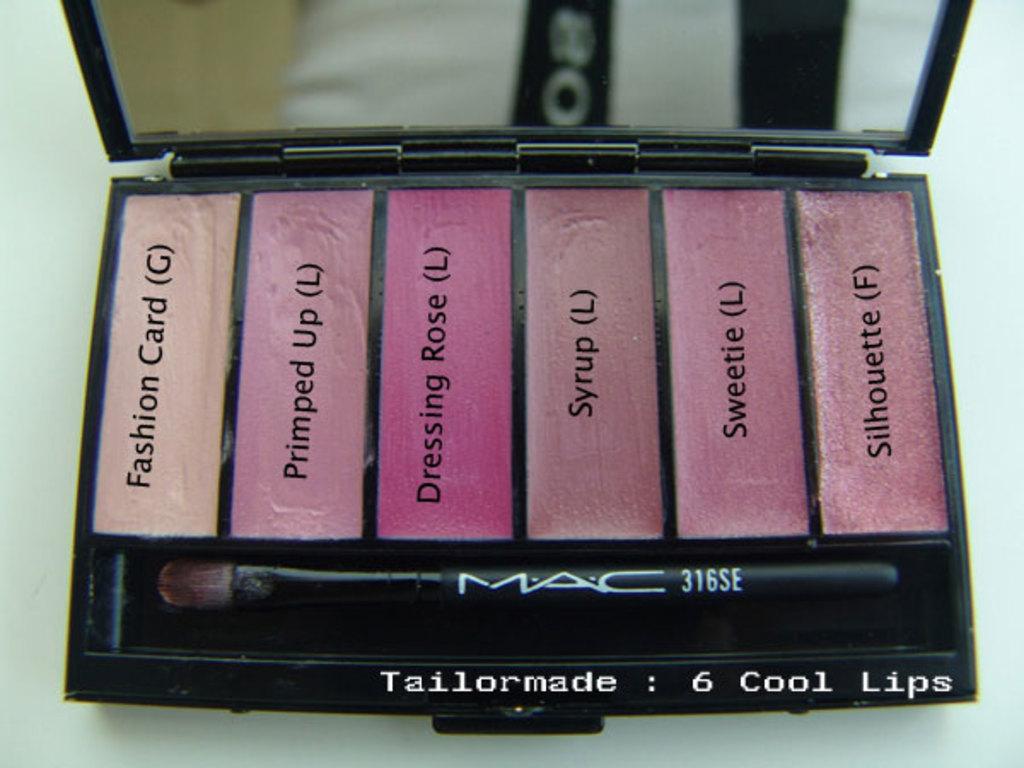What are the names of these shades of lip color?
Offer a very short reply. Fashion card, primped up, dressing rose, syrup, sweetie, silhouette. How  many cool lips are in this product?
Ensure brevity in your answer.  6. 